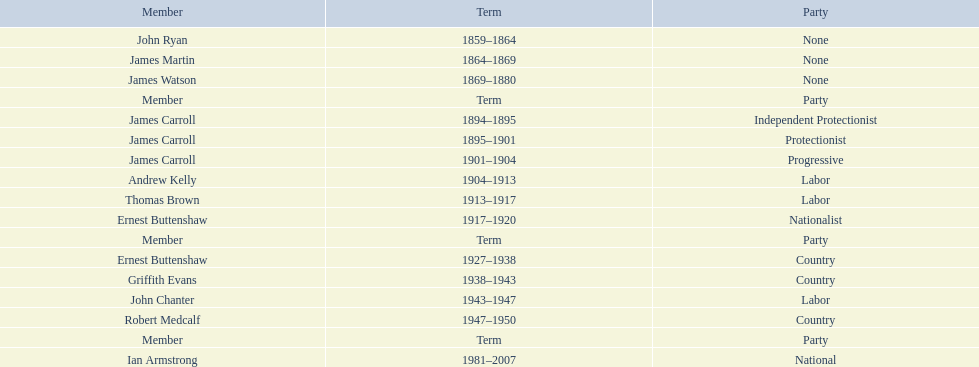Which member of the second incarnation of the lachlan was also a nationalist? Ernest Buttenshaw. 